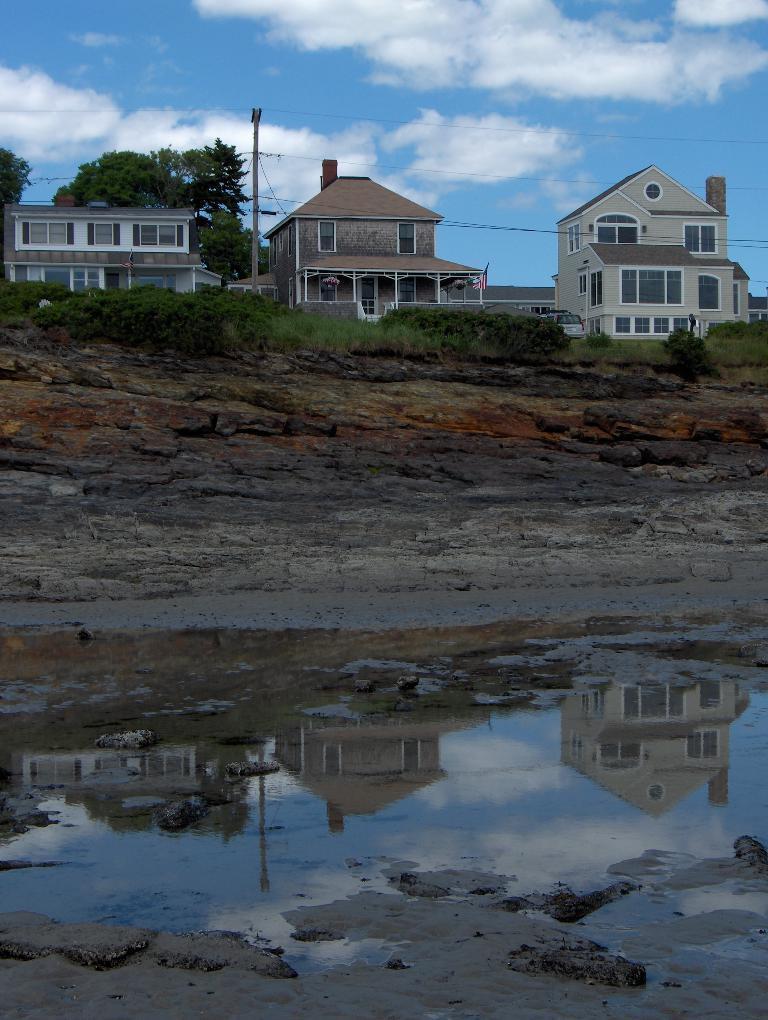Could you give a brief overview of what you see in this image? In this image in the background there are some houses, trees, board and some wires and grass. At the bottom there are some water, at the top of the image there is sky. 